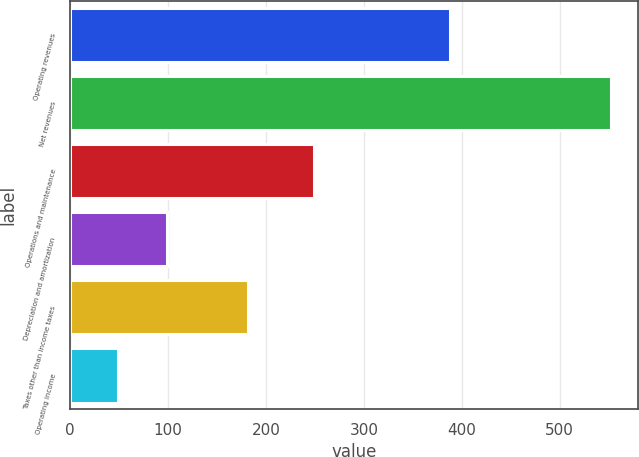<chart> <loc_0><loc_0><loc_500><loc_500><bar_chart><fcel>Operating revenues<fcel>Net revenues<fcel>Operations and maintenance<fcel>Depreciation and amortization<fcel>Taxes other than income taxes<fcel>Operating income<nl><fcel>388<fcel>552<fcel>249<fcel>99.3<fcel>182<fcel>49<nl></chart> 